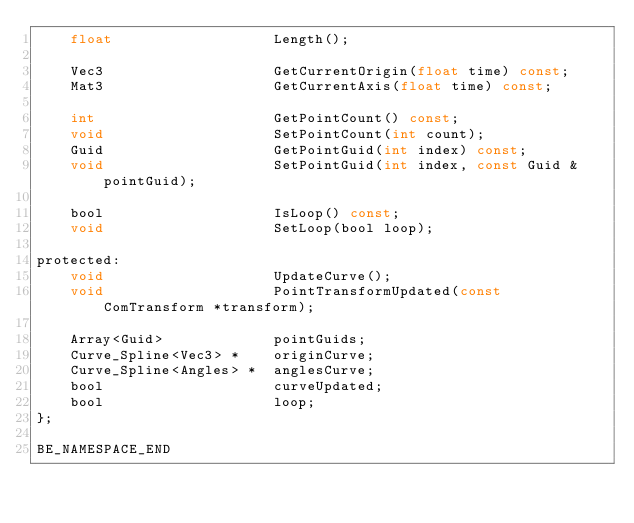Convert code to text. <code><loc_0><loc_0><loc_500><loc_500><_C_>    float                   Length();

    Vec3                    GetCurrentOrigin(float time) const;
    Mat3                    GetCurrentAxis(float time) const;

    int                     GetPointCount() const;
    void                    SetPointCount(int count);
    Guid                    GetPointGuid(int index) const;
    void                    SetPointGuid(int index, const Guid &pointGuid);

    bool                    IsLoop() const;
    void                    SetLoop(bool loop);

protected:
    void                    UpdateCurve();
    void                    PointTransformUpdated(const ComTransform *transform);

    Array<Guid>             pointGuids;
    Curve_Spline<Vec3> *    originCurve;
    Curve_Spline<Angles> *  anglesCurve;
    bool                    curveUpdated;
    bool                    loop;
};

BE_NAMESPACE_END
</code> 